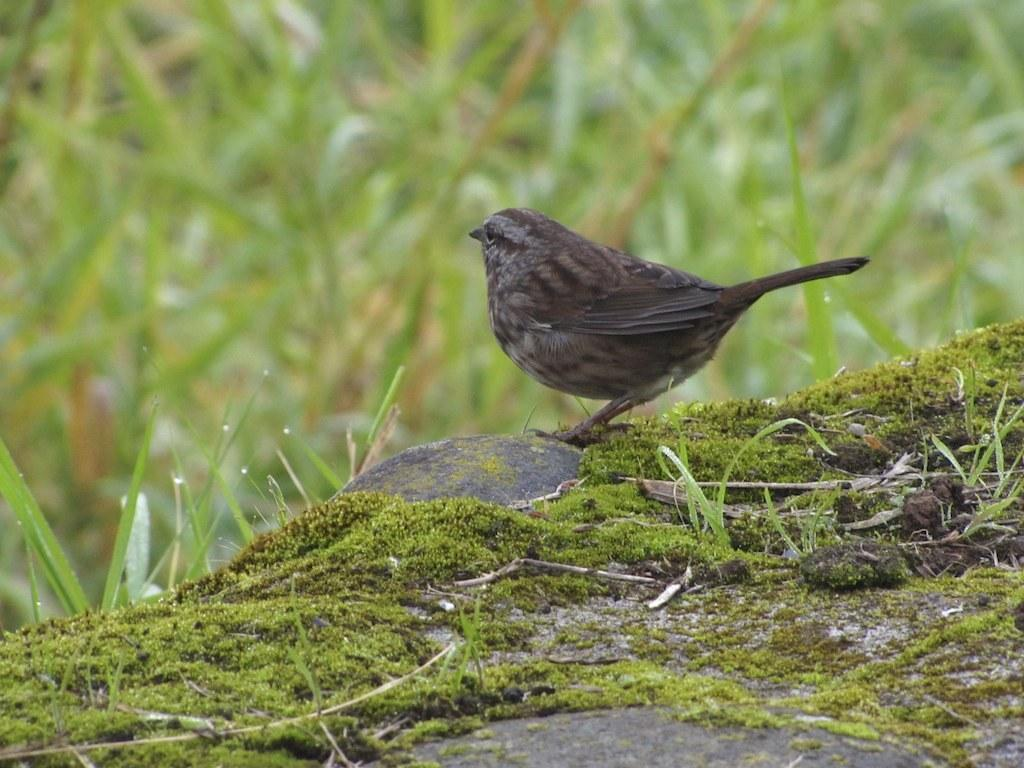What type of animal can be seen in the image? There is a bird in the image. Where is the bird located? The bird is on a rock. What is present on the rock with the bird? There is grass and fungi on the rock. What can be seen in the background behind the bird? There is a group of plants visible behind the bird. What type of pancake is the bird eating in the image? There is no pancake present in the image, and the bird is not shown eating anything. 